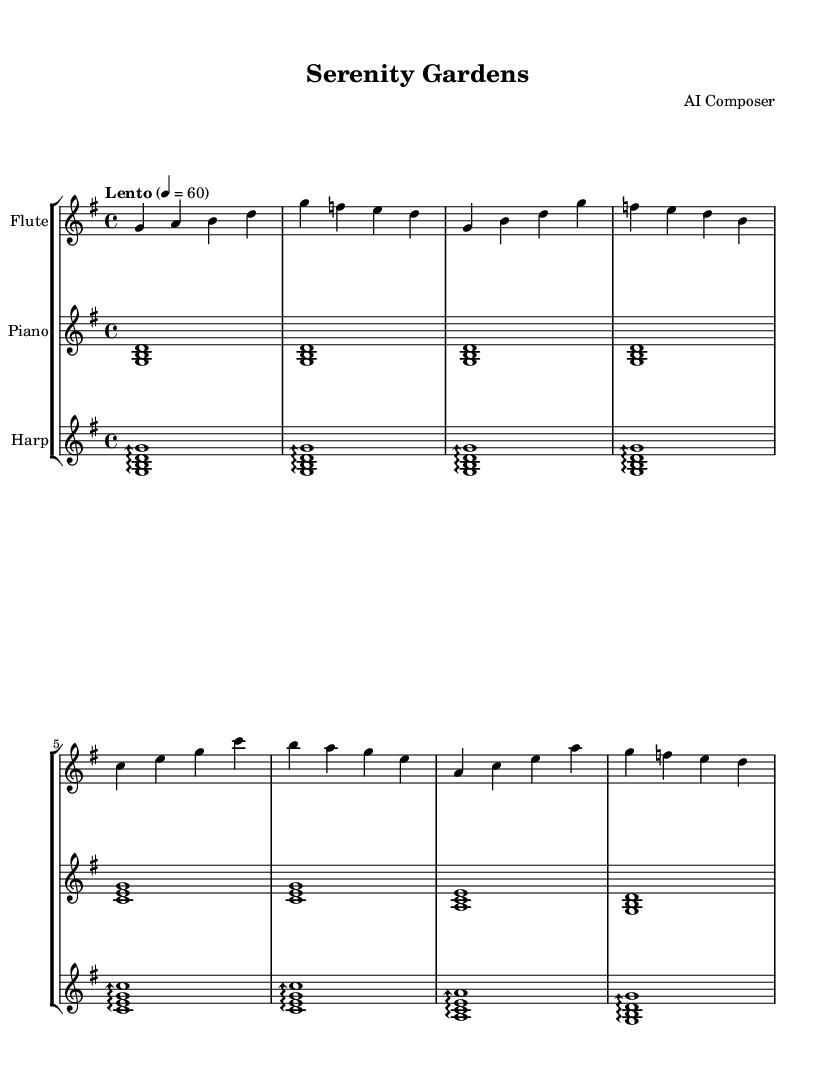What is the key signature of this music? The key signature is G major, which has one sharp (F#). This can be determined from the key signature indicated at the beginning of the score.
Answer: G major What is the time signature of this music? The time signature is 4/4, which indicates four beats per measure, and can be observed at the start of the score.
Answer: 4/4 What is the tempo marking for this piece? The tempo marking is "Lento," which indicates a slow pace, typically around 60 beats per minute. This is mentioned under the tempo indication at the beginning of the score.
Answer: Lento How many sections are present in the music? The music has two main sections: an A section and a partial B section. The A section is specified in the music, and the B section is also noted but labeled as partial.
Answer: Two sections What instruments are used in this composition? The instruments used in this composition are flute, piano, and harp. Each instrument is labeled at the start of its corresponding staff in the score.
Answer: Flute, piano, harp What does the arpeggio marking signify in this music? The arpeggio marking indicates that the notes should be played in a broken manner, one after the other, rather than simultaneously. It can be identified near the harp staff where the arpeggio is explicitly indicated.
Answer: Broken chord Which instrument primarily carries the melody in the A section? The flute primarily carries the melody in the A section, as it plays the main thematic material that is prominent in this part of the score.
Answer: Flute 